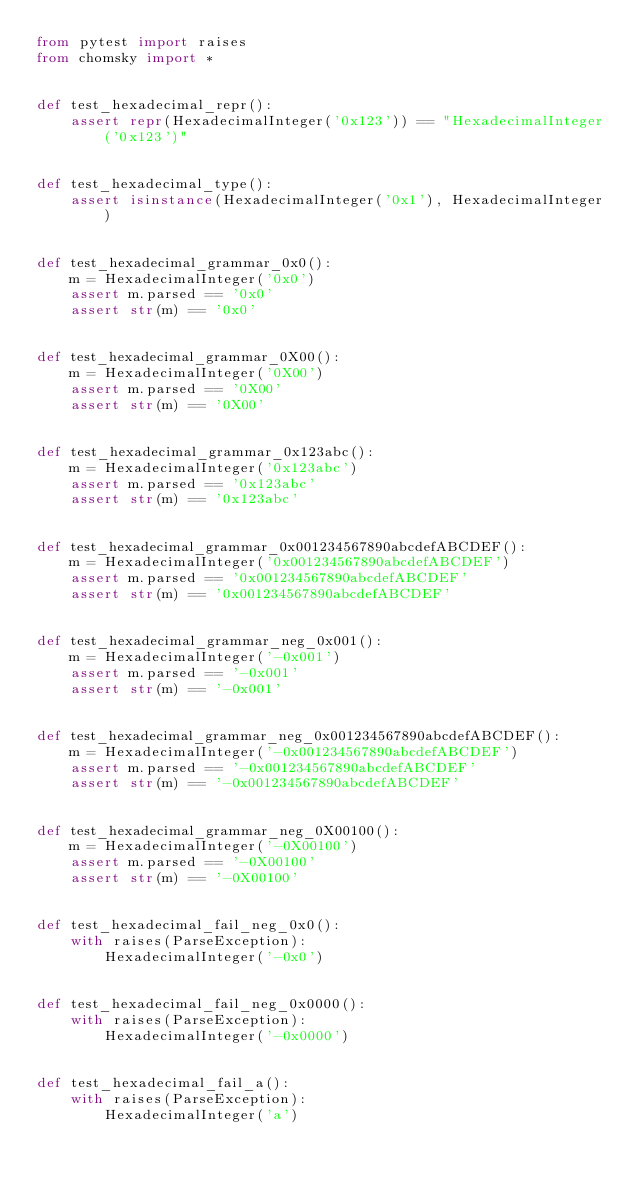<code> <loc_0><loc_0><loc_500><loc_500><_Python_>from pytest import raises
from chomsky import *


def test_hexadecimal_repr():
    assert repr(HexadecimalInteger('0x123')) == "HexadecimalInteger('0x123')"


def test_hexadecimal_type():
    assert isinstance(HexadecimalInteger('0x1'), HexadecimalInteger)


def test_hexadecimal_grammar_0x0():
    m = HexadecimalInteger('0x0')
    assert m.parsed == '0x0'
    assert str(m) == '0x0'


def test_hexadecimal_grammar_0X00():
    m = HexadecimalInteger('0X00')
    assert m.parsed == '0X00'
    assert str(m) == '0X00'


def test_hexadecimal_grammar_0x123abc():
    m = HexadecimalInteger('0x123abc')
    assert m.parsed == '0x123abc'
    assert str(m) == '0x123abc'


def test_hexadecimal_grammar_0x001234567890abcdefABCDEF():
    m = HexadecimalInteger('0x001234567890abcdefABCDEF')
    assert m.parsed == '0x001234567890abcdefABCDEF'
    assert str(m) == '0x001234567890abcdefABCDEF'


def test_hexadecimal_grammar_neg_0x001():
    m = HexadecimalInteger('-0x001')
    assert m.parsed == '-0x001'
    assert str(m) == '-0x001'


def test_hexadecimal_grammar_neg_0x001234567890abcdefABCDEF():
    m = HexadecimalInteger('-0x001234567890abcdefABCDEF')
    assert m.parsed == '-0x001234567890abcdefABCDEF'
    assert str(m) == '-0x001234567890abcdefABCDEF'


def test_hexadecimal_grammar_neg_0X00100():
    m = HexadecimalInteger('-0X00100')
    assert m.parsed == '-0X00100'
    assert str(m) == '-0X00100'


def test_hexadecimal_fail_neg_0x0():
    with raises(ParseException):
        HexadecimalInteger('-0x0')


def test_hexadecimal_fail_neg_0x0000():
    with raises(ParseException):
        HexadecimalInteger('-0x0000')


def test_hexadecimal_fail_a():
    with raises(ParseException):
        HexadecimalInteger('a')
</code> 